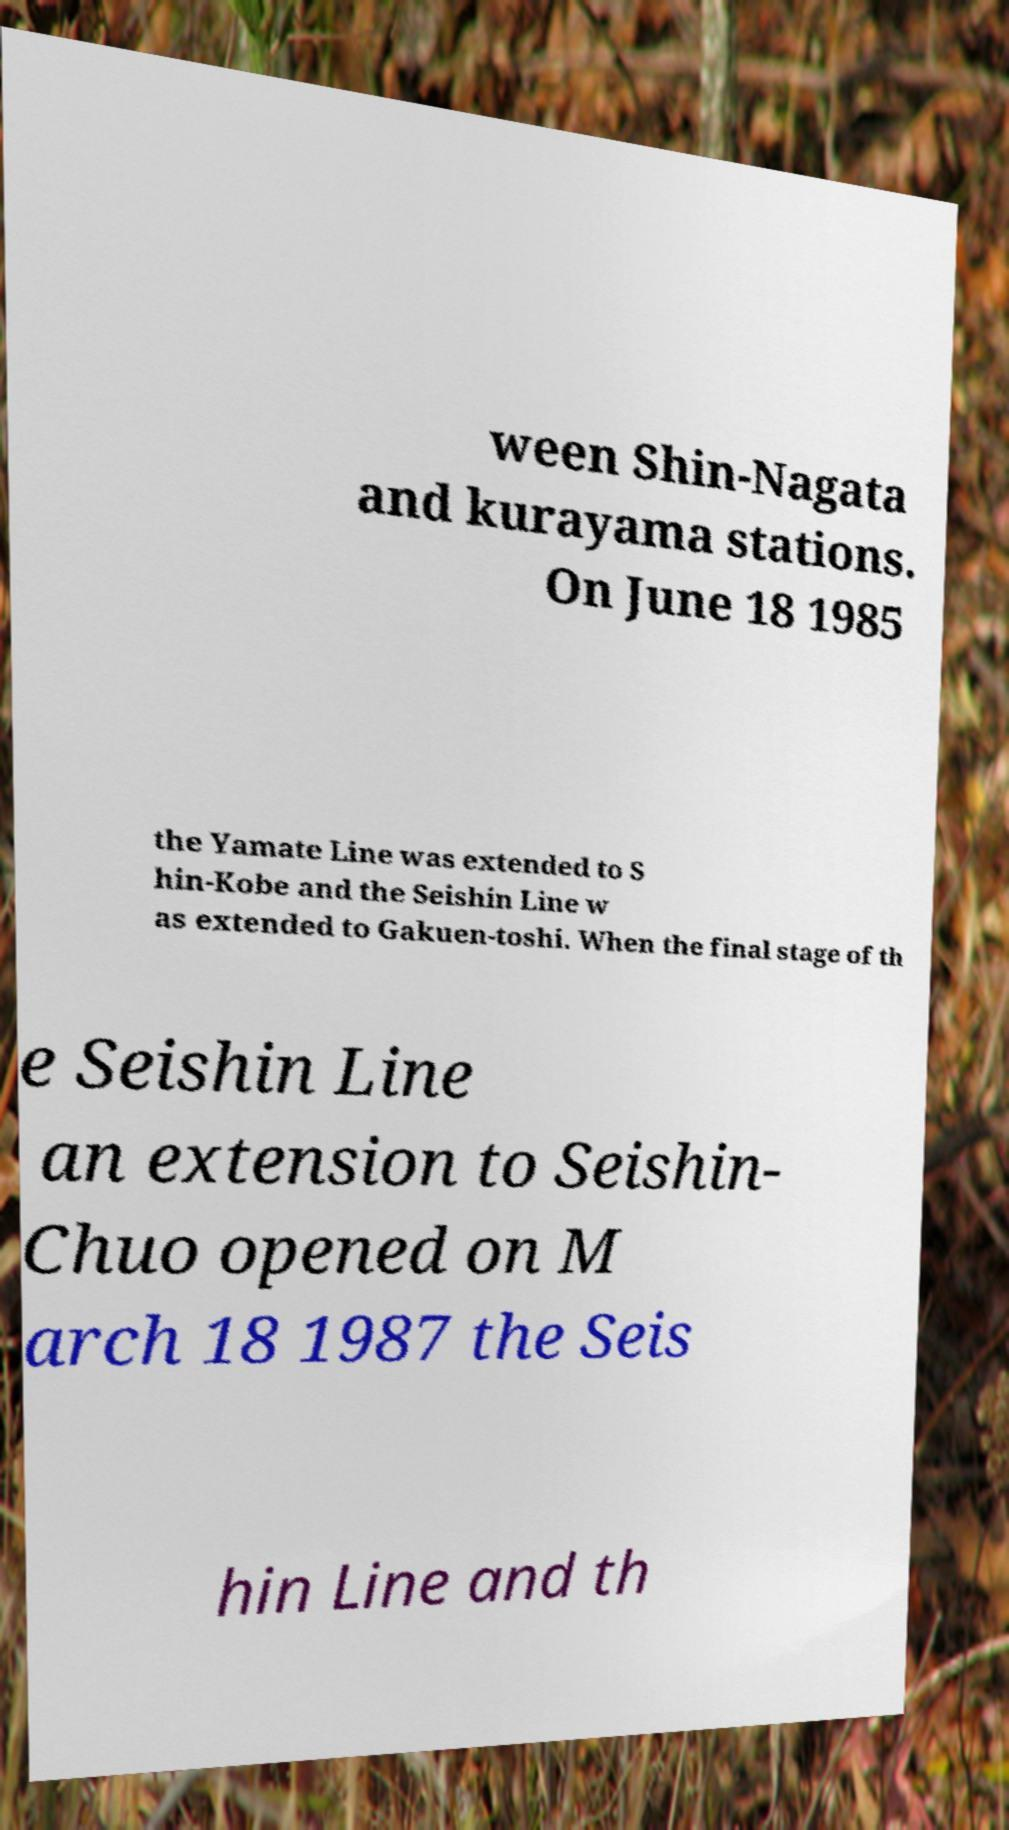Please read and relay the text visible in this image. What does it say? ween Shin-Nagata and kurayama stations. On June 18 1985 the Yamate Line was extended to S hin-Kobe and the Seishin Line w as extended to Gakuen-toshi. When the final stage of th e Seishin Line an extension to Seishin- Chuo opened on M arch 18 1987 the Seis hin Line and th 